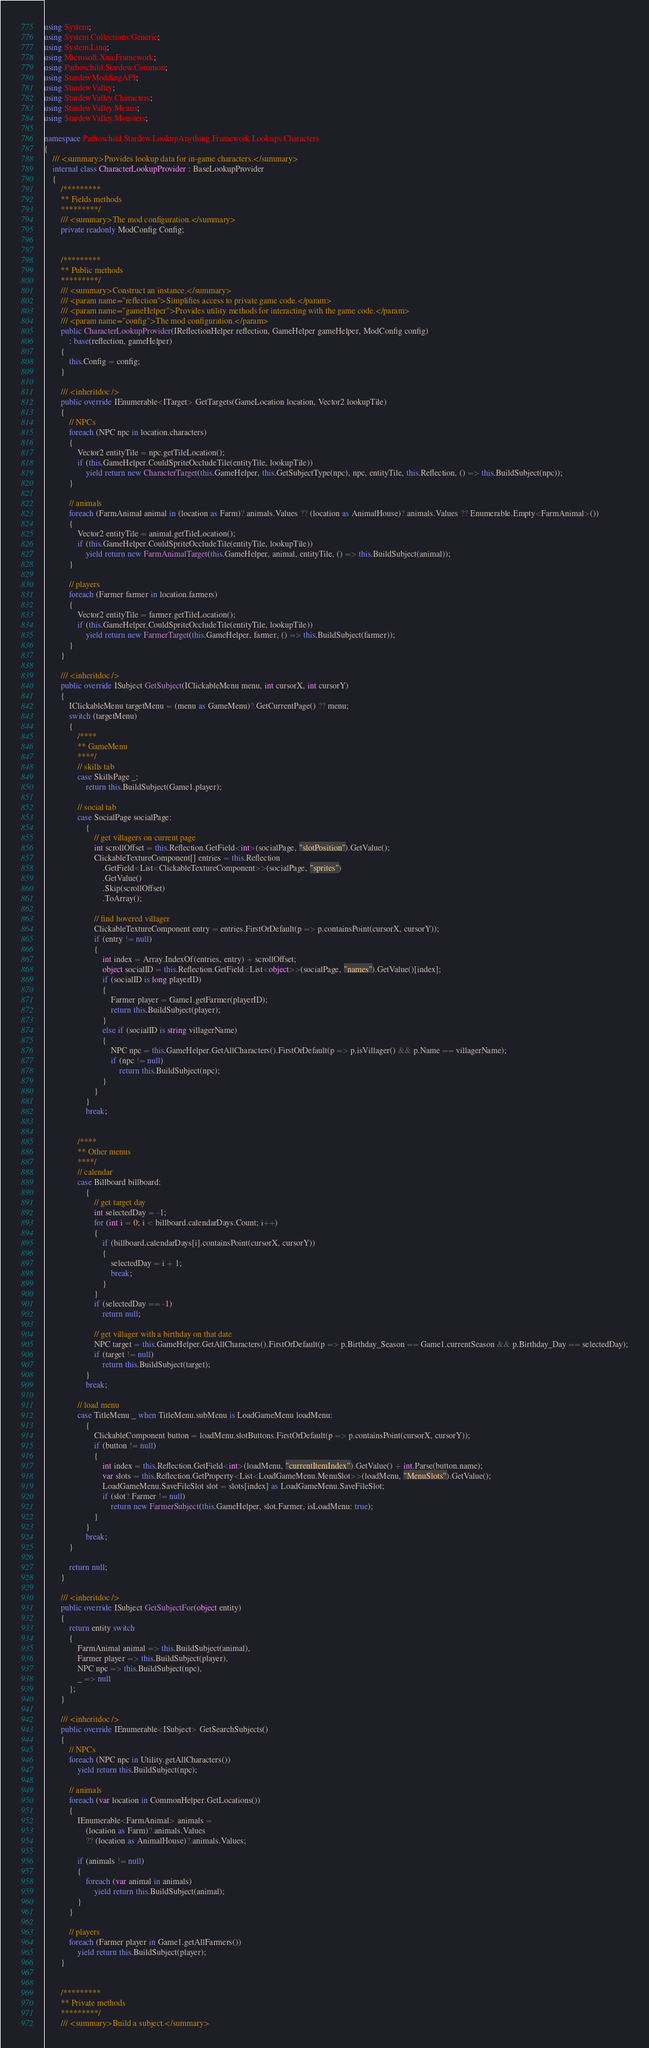Convert code to text. <code><loc_0><loc_0><loc_500><loc_500><_C#_>using System;
using System.Collections.Generic;
using System.Linq;
using Microsoft.Xna.Framework;
using Pathoschild.Stardew.Common;
using StardewModdingAPI;
using StardewValley;
using StardewValley.Characters;
using StardewValley.Menus;
using StardewValley.Monsters;

namespace Pathoschild.Stardew.LookupAnything.Framework.Lookups.Characters
{
    /// <summary>Provides lookup data for in-game characters.</summary>
    internal class CharacterLookupProvider : BaseLookupProvider
    {
        /*********
        ** Fields methods
        *********/
        /// <summary>The mod configuration.</summary>
        private readonly ModConfig Config;


        /*********
        ** Public methods
        *********/
        /// <summary>Construct an instance.</summary>
        /// <param name="reflection">Simplifies access to private game code.</param>
        /// <param name="gameHelper">Provides utility methods for interacting with the game code.</param>
        /// <param name="config">The mod configuration.</param>
        public CharacterLookupProvider(IReflectionHelper reflection, GameHelper gameHelper, ModConfig config)
            : base(reflection, gameHelper)
        {
            this.Config = config;
        }

        /// <inheritdoc />
        public override IEnumerable<ITarget> GetTargets(GameLocation location, Vector2 lookupTile)
        {
            // NPCs
            foreach (NPC npc in location.characters)
            {
                Vector2 entityTile = npc.getTileLocation();
                if (this.GameHelper.CouldSpriteOccludeTile(entityTile, lookupTile))
                    yield return new CharacterTarget(this.GameHelper, this.GetSubjectType(npc), npc, entityTile, this.Reflection, () => this.BuildSubject(npc));
            }

            // animals
            foreach (FarmAnimal animal in (location as Farm)?.animals.Values ?? (location as AnimalHouse)?.animals.Values ?? Enumerable.Empty<FarmAnimal>())
            {
                Vector2 entityTile = animal.getTileLocation();
                if (this.GameHelper.CouldSpriteOccludeTile(entityTile, lookupTile))
                    yield return new FarmAnimalTarget(this.GameHelper, animal, entityTile, () => this.BuildSubject(animal));
            }

            // players
            foreach (Farmer farmer in location.farmers)
            {
                Vector2 entityTile = farmer.getTileLocation();
                if (this.GameHelper.CouldSpriteOccludeTile(entityTile, lookupTile))
                    yield return new FarmerTarget(this.GameHelper, farmer, () => this.BuildSubject(farmer));
            }
        }

        /// <inheritdoc />
        public override ISubject GetSubject(IClickableMenu menu, int cursorX, int cursorY)
        {
            IClickableMenu targetMenu = (menu as GameMenu)?.GetCurrentPage() ?? menu;
            switch (targetMenu)
            {
                /****
                ** GameMenu
                ****/
                // skills tab
                case SkillsPage _:
                    return this.BuildSubject(Game1.player);

                // social tab
                case SocialPage socialPage:
                    {
                        // get villagers on current page
                        int scrollOffset = this.Reflection.GetField<int>(socialPage, "slotPosition").GetValue();
                        ClickableTextureComponent[] entries = this.Reflection
                            .GetField<List<ClickableTextureComponent>>(socialPage, "sprites")
                            .GetValue()
                            .Skip(scrollOffset)
                            .ToArray();

                        // find hovered villager
                        ClickableTextureComponent entry = entries.FirstOrDefault(p => p.containsPoint(cursorX, cursorY));
                        if (entry != null)
                        {
                            int index = Array.IndexOf(entries, entry) + scrollOffset;
                            object socialID = this.Reflection.GetField<List<object>>(socialPage, "names").GetValue()[index];
                            if (socialID is long playerID)
                            {
                                Farmer player = Game1.getFarmer(playerID);
                                return this.BuildSubject(player);
                            }
                            else if (socialID is string villagerName)
                            {
                                NPC npc = this.GameHelper.GetAllCharacters().FirstOrDefault(p => p.isVillager() && p.Name == villagerName);
                                if (npc != null)
                                    return this.BuildSubject(npc);
                            }
                        }
                    }
                    break;


                /****
                ** Other menus
                ****/
                // calendar
                case Billboard billboard:
                    {
                        // get target day
                        int selectedDay = -1;
                        for (int i = 0; i < billboard.calendarDays.Count; i++)
                        {
                            if (billboard.calendarDays[i].containsPoint(cursorX, cursorY))
                            {
                                selectedDay = i + 1;
                                break;
                            }
                        }
                        if (selectedDay == -1)
                            return null;

                        // get villager with a birthday on that date
                        NPC target = this.GameHelper.GetAllCharacters().FirstOrDefault(p => p.Birthday_Season == Game1.currentSeason && p.Birthday_Day == selectedDay);
                        if (target != null)
                            return this.BuildSubject(target);
                    }
                    break;

                // load menu
                case TitleMenu _ when TitleMenu.subMenu is LoadGameMenu loadMenu:
                    {
                        ClickableComponent button = loadMenu.slotButtons.FirstOrDefault(p => p.containsPoint(cursorX, cursorY));
                        if (button != null)
                        {
                            int index = this.Reflection.GetField<int>(loadMenu, "currentItemIndex").GetValue() + int.Parse(button.name);
                            var slots = this.Reflection.GetProperty<List<LoadGameMenu.MenuSlot>>(loadMenu, "MenuSlots").GetValue();
                            LoadGameMenu.SaveFileSlot slot = slots[index] as LoadGameMenu.SaveFileSlot;
                            if (slot?.Farmer != null)
                                return new FarmerSubject(this.GameHelper, slot.Farmer, isLoadMenu: true);
                        }
                    }
                    break;
            }

            return null;
        }

        /// <inheritdoc />
        public override ISubject GetSubjectFor(object entity)
        {
            return entity switch
            {
                FarmAnimal animal => this.BuildSubject(animal),
                Farmer player => this.BuildSubject(player),
                NPC npc => this.BuildSubject(npc),
                _ => null
            };
        }

        /// <inheritdoc />
        public override IEnumerable<ISubject> GetSearchSubjects()
        {
            // NPCs
            foreach (NPC npc in Utility.getAllCharacters())
                yield return this.BuildSubject(npc);

            // animals
            foreach (var location in CommonHelper.GetLocations())
            {
                IEnumerable<FarmAnimal> animals =
                    (location as Farm)?.animals.Values
                    ?? (location as AnimalHouse)?.animals.Values;

                if (animals != null)
                {
                    foreach (var animal in animals)
                        yield return this.BuildSubject(animal);
                }
            }

            // players
            foreach (Farmer player in Game1.getAllFarmers())
                yield return this.BuildSubject(player);
        }


        /*********
        ** Private methods
        *********/
        /// <summary>Build a subject.</summary></code> 